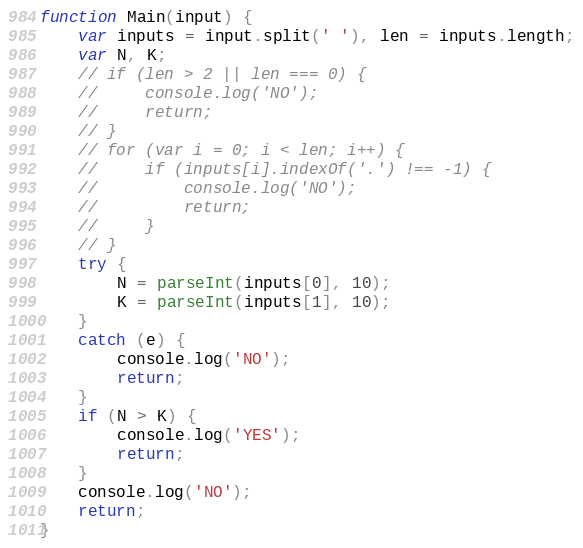Convert code to text. <code><loc_0><loc_0><loc_500><loc_500><_JavaScript_>function Main(input) {
    var inputs = input.split(' '), len = inputs.length;
    var N, K;
    // if (len > 2 || len === 0) {
    //     console.log('NO');
    //     return;
    // }
    // for (var i = 0; i < len; i++) {
    //     if (inputs[i].indexOf('.') !== -1) {
    //         console.log('NO');
    //         return;
    //     }
    // }
    try {
        N = parseInt(inputs[0], 10);
        K = parseInt(inputs[1], 10);
    }
    catch (e) {
        console.log('NO');
        return;
    }
    if (N > K) {
        console.log('YES');
        return;
    }
    console.log('NO');
    return;
}</code> 